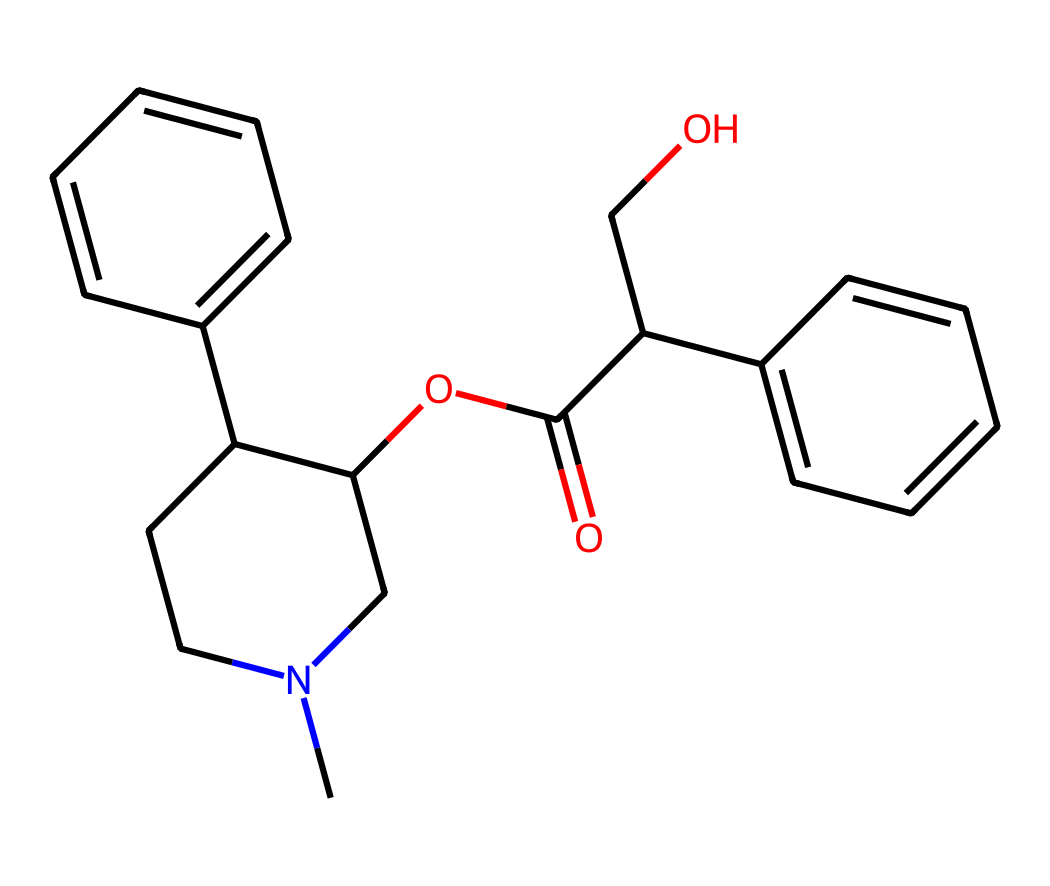What is the primary functional group present in atropine? The structure includes an ester functional group (OC(=O)), which is identifiable by the carbonyl (C=O) bonded to an oxygen atom.
Answer: ester How many carbon atoms are in the molecular structure of atropine? Counting the carbon atoms in the provided SMILES representation yields a total of 20 carbon atoms as present in the alkaloid structure.
Answer: 20 Does the structure of atropine include nitrogen atoms? Yes, the structure contains one nitrogen atom, which is visually represented in the ring system of the molecule.
Answer: yes What type of chemical compound is atropine classified as? Atropine is classified as an alkaloid, similar to many other plant-derived compounds that have nitrogen in their structure.
Answer: alkaloid What is the molecular weight of atropine? The molecular weight can be derived from the individual atomic weights of all constituent atoms, resulting in approximately 303.37 g/mol for atropine.
Answer: 303.37 Which part of the structure indicates its therapeutic potential? The presence of the nitrogen atom within a cyclic structure is characteristic of alkaloids, which often exhibit medicinal properties, indicating its therapeutic potential.
Answer: nitrogen How many aromatic rings are present in atropine's structure? The structure contains two aromatic rings, identifiable by the alternating double bonds in the carbon chain.
Answer: 2 